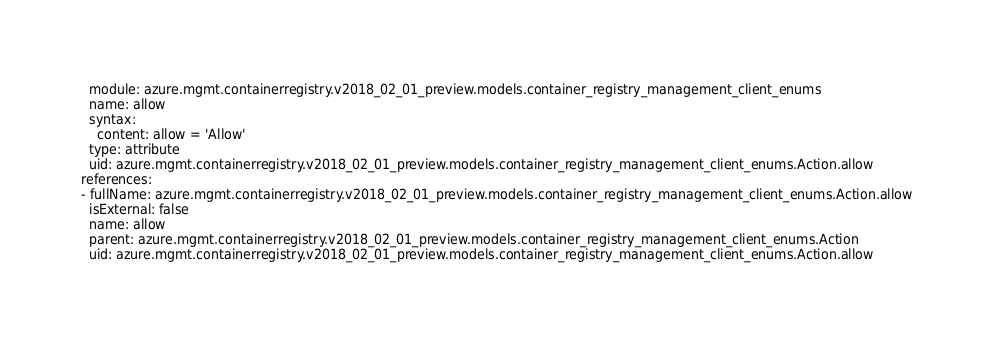<code> <loc_0><loc_0><loc_500><loc_500><_YAML_>  module: azure.mgmt.containerregistry.v2018_02_01_preview.models.container_registry_management_client_enums
  name: allow
  syntax:
    content: allow = 'Allow'
  type: attribute
  uid: azure.mgmt.containerregistry.v2018_02_01_preview.models.container_registry_management_client_enums.Action.allow
references:
- fullName: azure.mgmt.containerregistry.v2018_02_01_preview.models.container_registry_management_client_enums.Action.allow
  isExternal: false
  name: allow
  parent: azure.mgmt.containerregistry.v2018_02_01_preview.models.container_registry_management_client_enums.Action
  uid: azure.mgmt.containerregistry.v2018_02_01_preview.models.container_registry_management_client_enums.Action.allow
</code> 